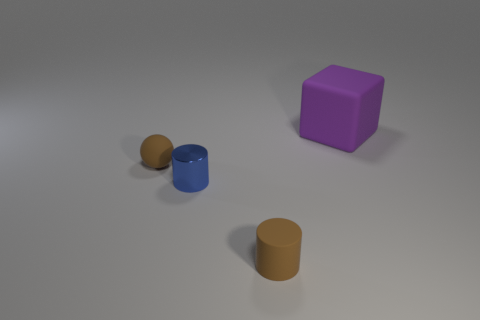There is a matte object that is the same color as the tiny matte cylinder; what is its size?
Provide a short and direct response. Small. There is a matte thing that is the same color as the tiny sphere; what shape is it?
Make the answer very short. Cylinder. How many small rubber objects are the same color as the small matte sphere?
Offer a terse response. 1. There is a brown matte thing that is the same shape as the small shiny object; what is its size?
Give a very brief answer. Small. Is there any other thing that has the same size as the purple matte cube?
Your answer should be compact. No. Do the matte object that is to the left of the small rubber cylinder and the tiny rubber thing that is in front of the tiny brown sphere have the same color?
Provide a succinct answer. Yes. Are there any small rubber things that have the same shape as the tiny blue shiny thing?
Make the answer very short. Yes. What number of other objects are the same color as the matte cylinder?
Provide a succinct answer. 1. There is a rubber ball that is behind the brown matte object that is in front of the small cylinder behind the brown matte cylinder; what is its color?
Ensure brevity in your answer.  Brown. Are there an equal number of purple rubber cubes on the left side of the tiny metallic thing and tiny purple objects?
Your answer should be very brief. Yes. 